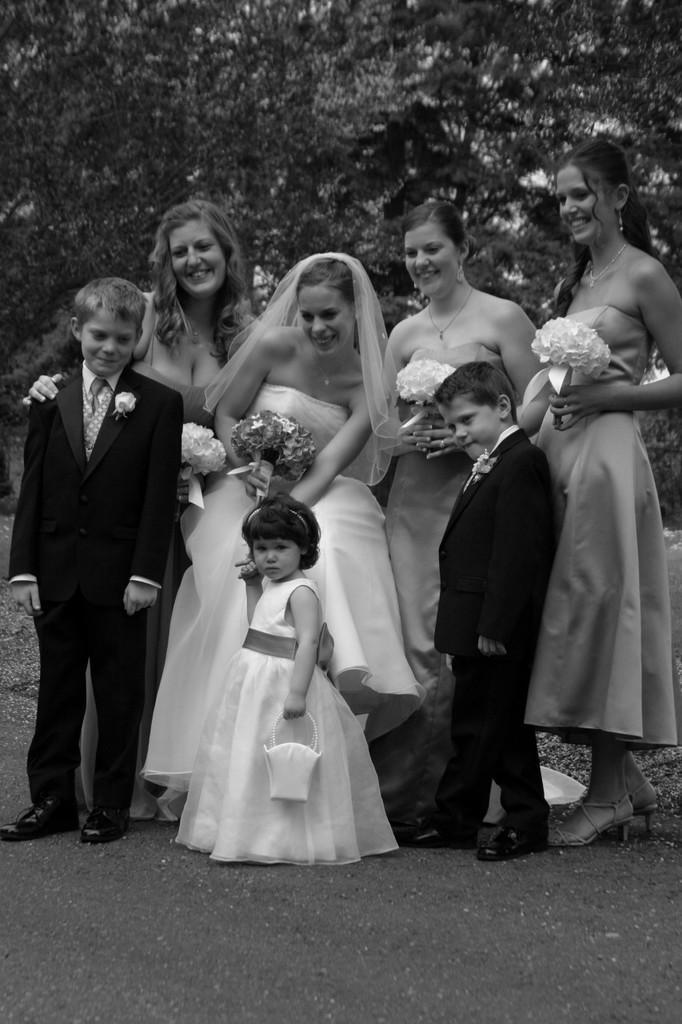How would you summarize this image in a sentence or two? It is a black and white image. In this image, we can see few women and kids are standing on the walkway. Few are holding flower bouquets. Here a girl is holding an object. In this image, we can see few people are smiling. Background we can see trees. 